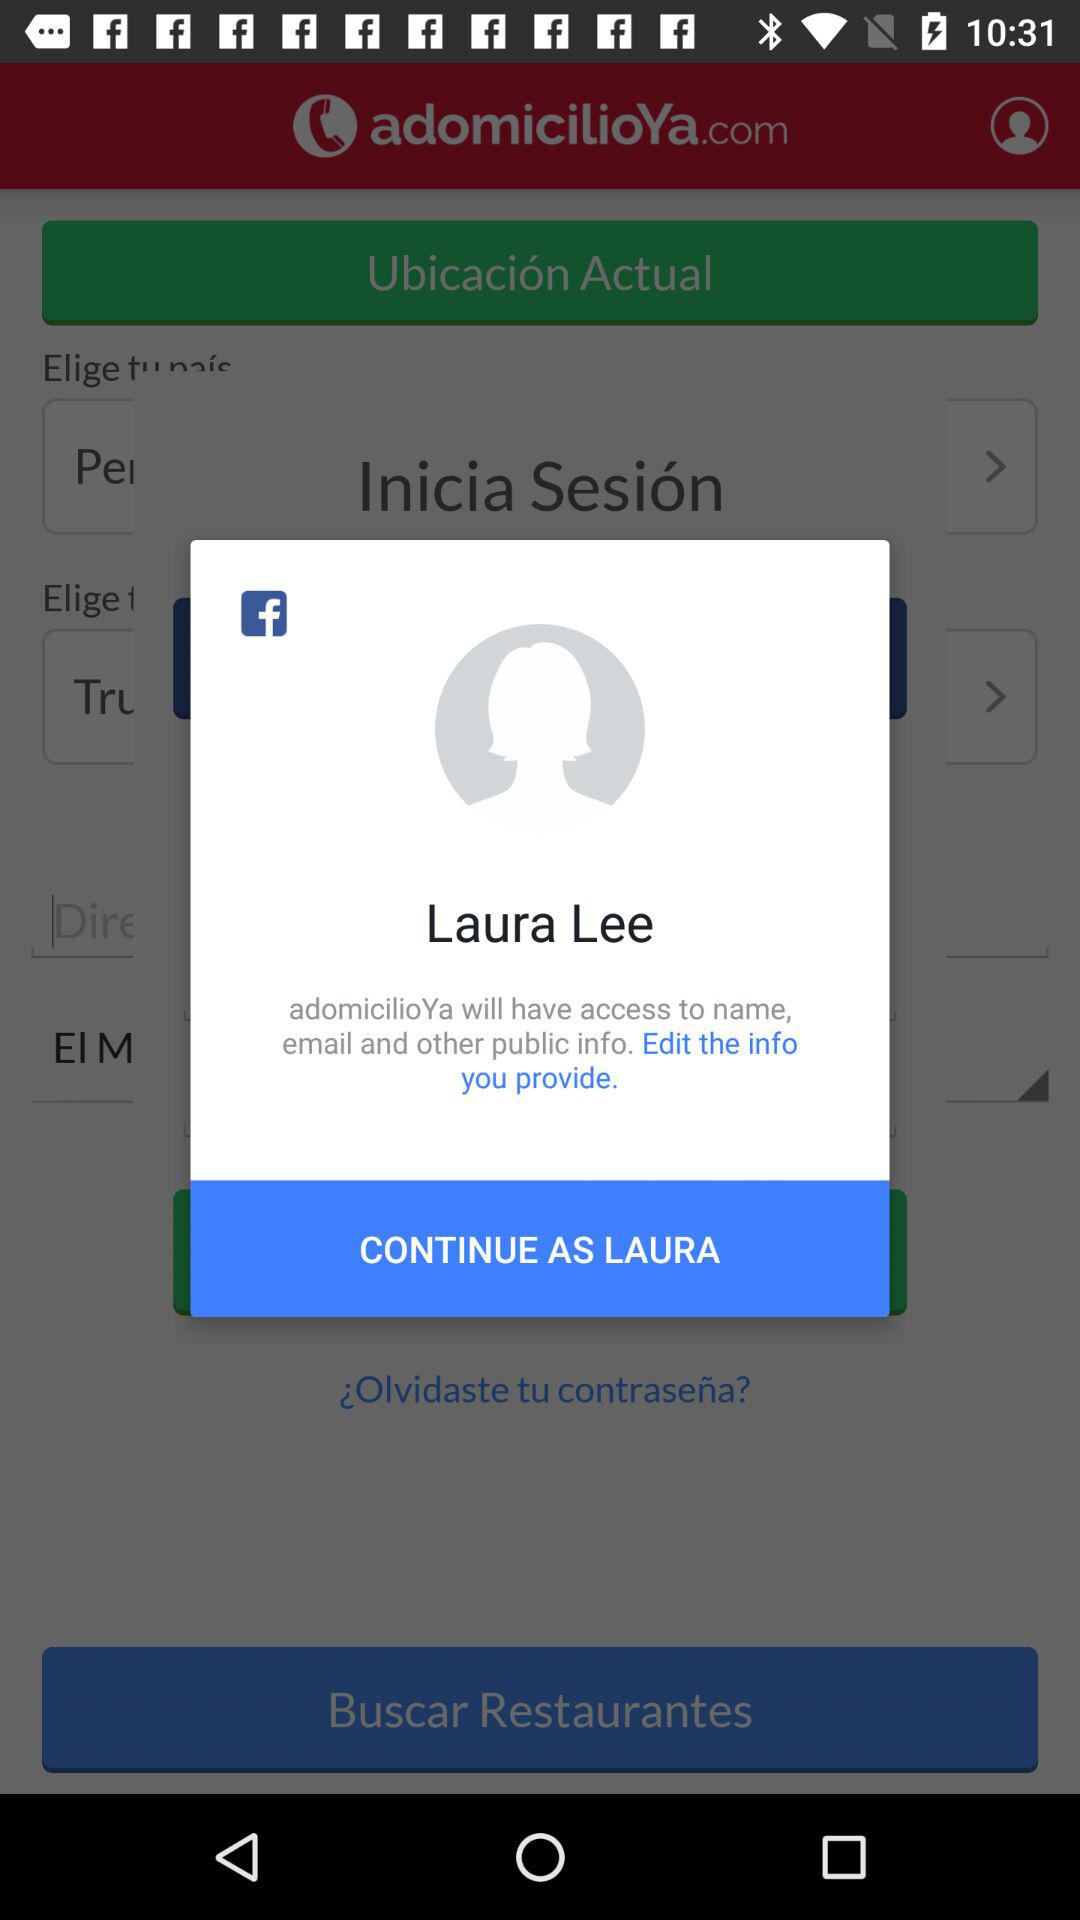What is the login name? The login name is Laura Lee. 